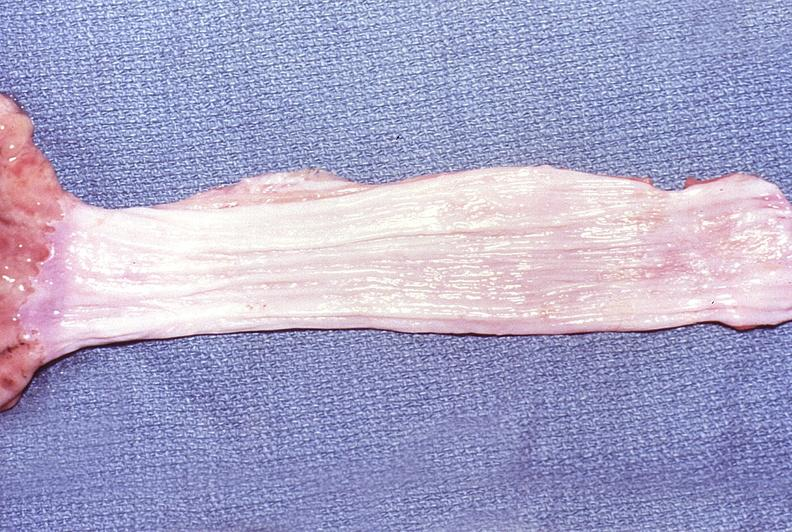s cardiovascular present?
Answer the question using a single word or phrase. No 